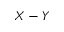<formula> <loc_0><loc_0><loc_500><loc_500>X - Y</formula> 